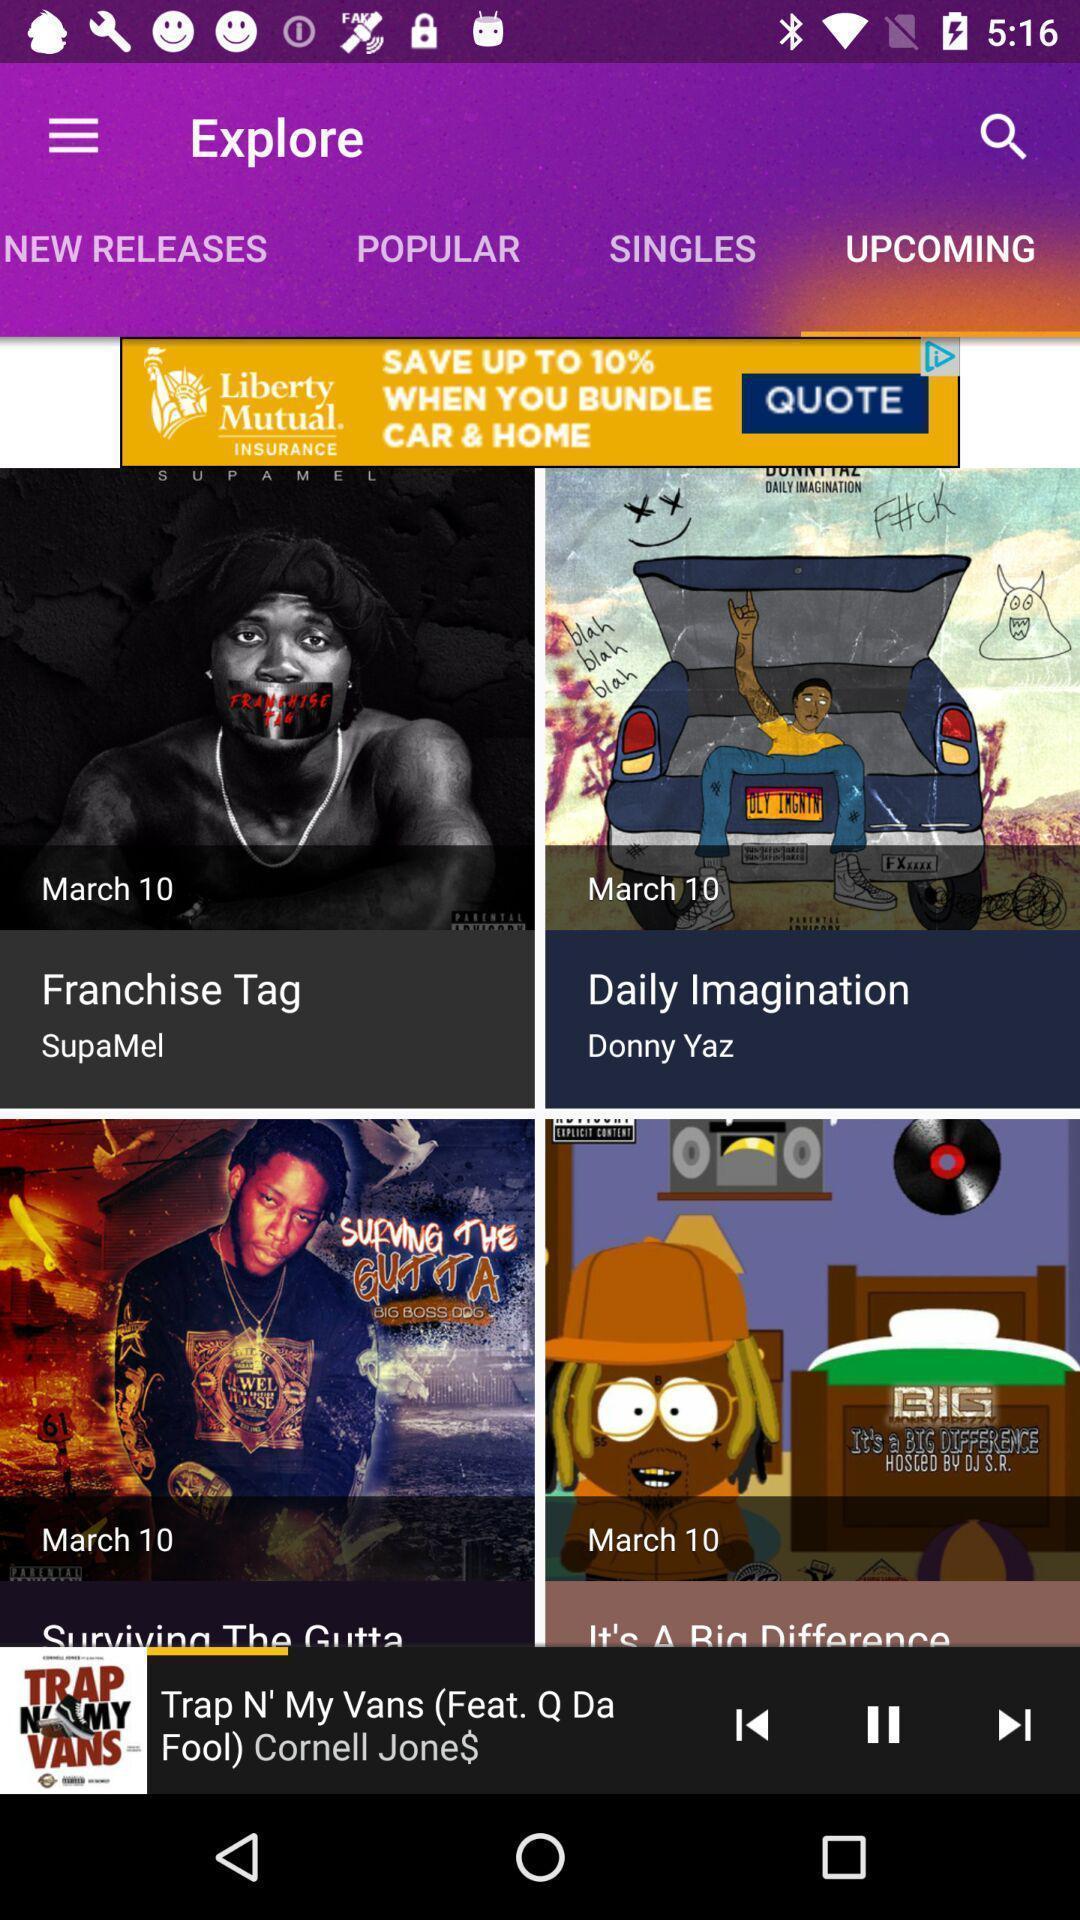Give me a narrative description of this picture. Page showing various titles in a music mixing app. 